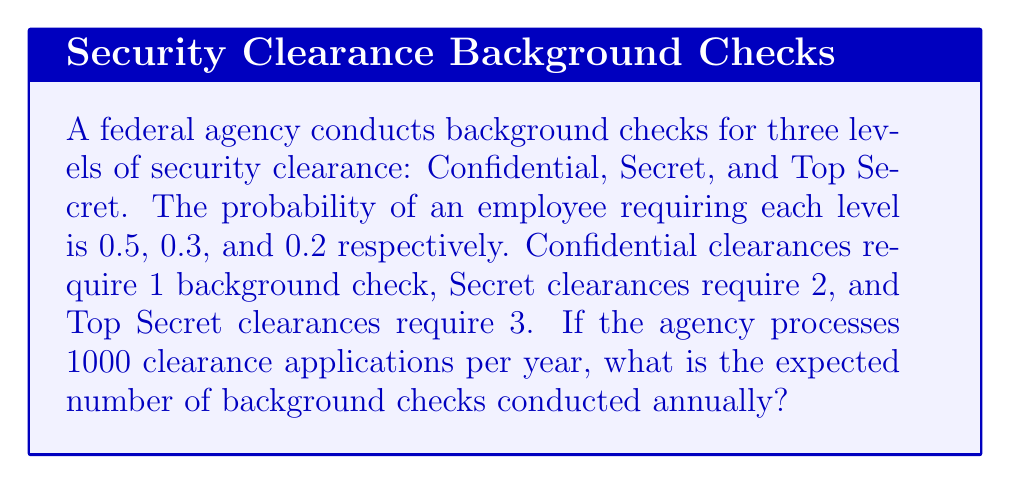Show me your answer to this math problem. Let's approach this step-by-step:

1) First, we need to define our random variable. Let $X$ be the number of background checks required for a single clearance application.

2) We can calculate the expected value of $X$ using the following formula:
   $$E(X) = \sum_{i=1}^{n} x_i \cdot p(x_i)$$
   where $x_i$ is each possible value of $X$, and $p(x_i)$ is the probability of that value occurring.

3) In this case:
   - $P(X=1) = 0.5$ (Confidential)
   - $P(X=2) = 0.3$ (Secret)
   - $P(X=3) = 0.2$ (Top Secret)

4) Applying the formula:
   $$E(X) = 1 \cdot 0.5 + 2 \cdot 0.3 + 3 \cdot 0.2$$

5) Calculating:
   $$E(X) = 0.5 + 0.6 + 0.6 = 1.7$$

6) This means that, on average, each clearance application requires 1.7 background checks.

7) Since the agency processes 1000 applications per year, we multiply this expected value by 1000:
   $$1000 \cdot E(X) = 1000 \cdot 1.7 = 1700$$

Therefore, the expected number of background checks conducted annually is 1700.
Answer: 1700 background checks 